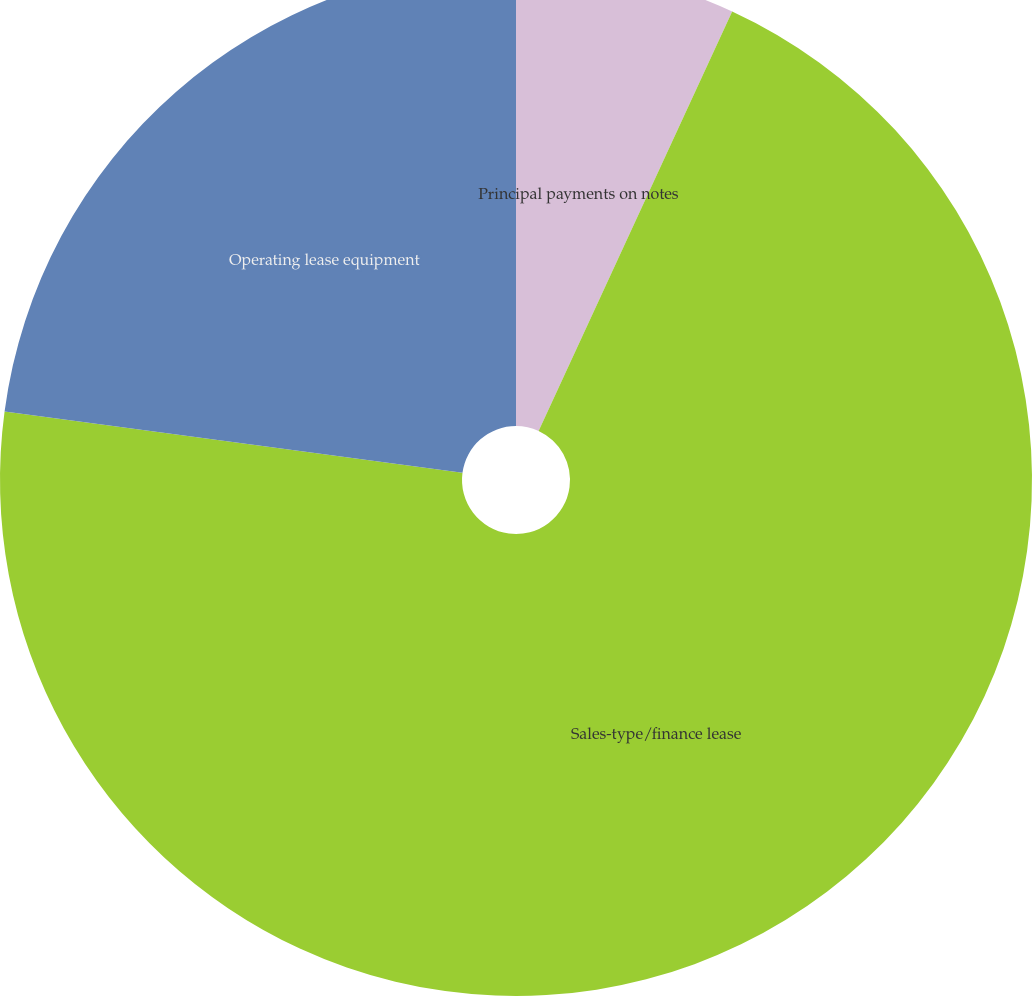Convert chart to OTSL. <chart><loc_0><loc_0><loc_500><loc_500><pie_chart><fcel>Principal payments on notes<fcel>Sales-type/finance lease<fcel>Operating lease equipment<nl><fcel>6.88%<fcel>70.24%<fcel>22.88%<nl></chart> 